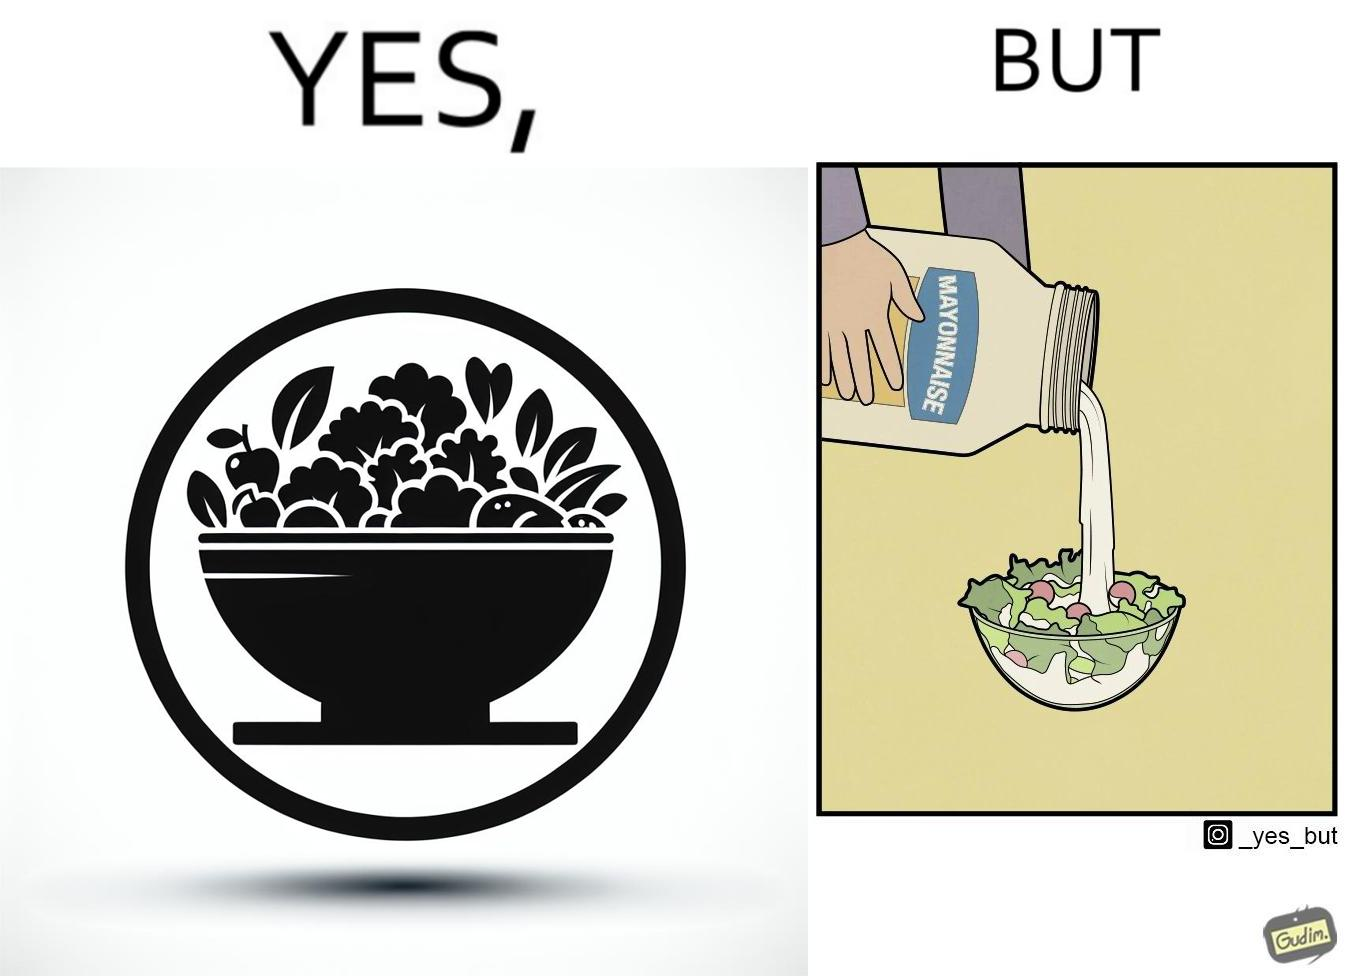Does this image contain satire or humor? Yes, this image is satirical. 